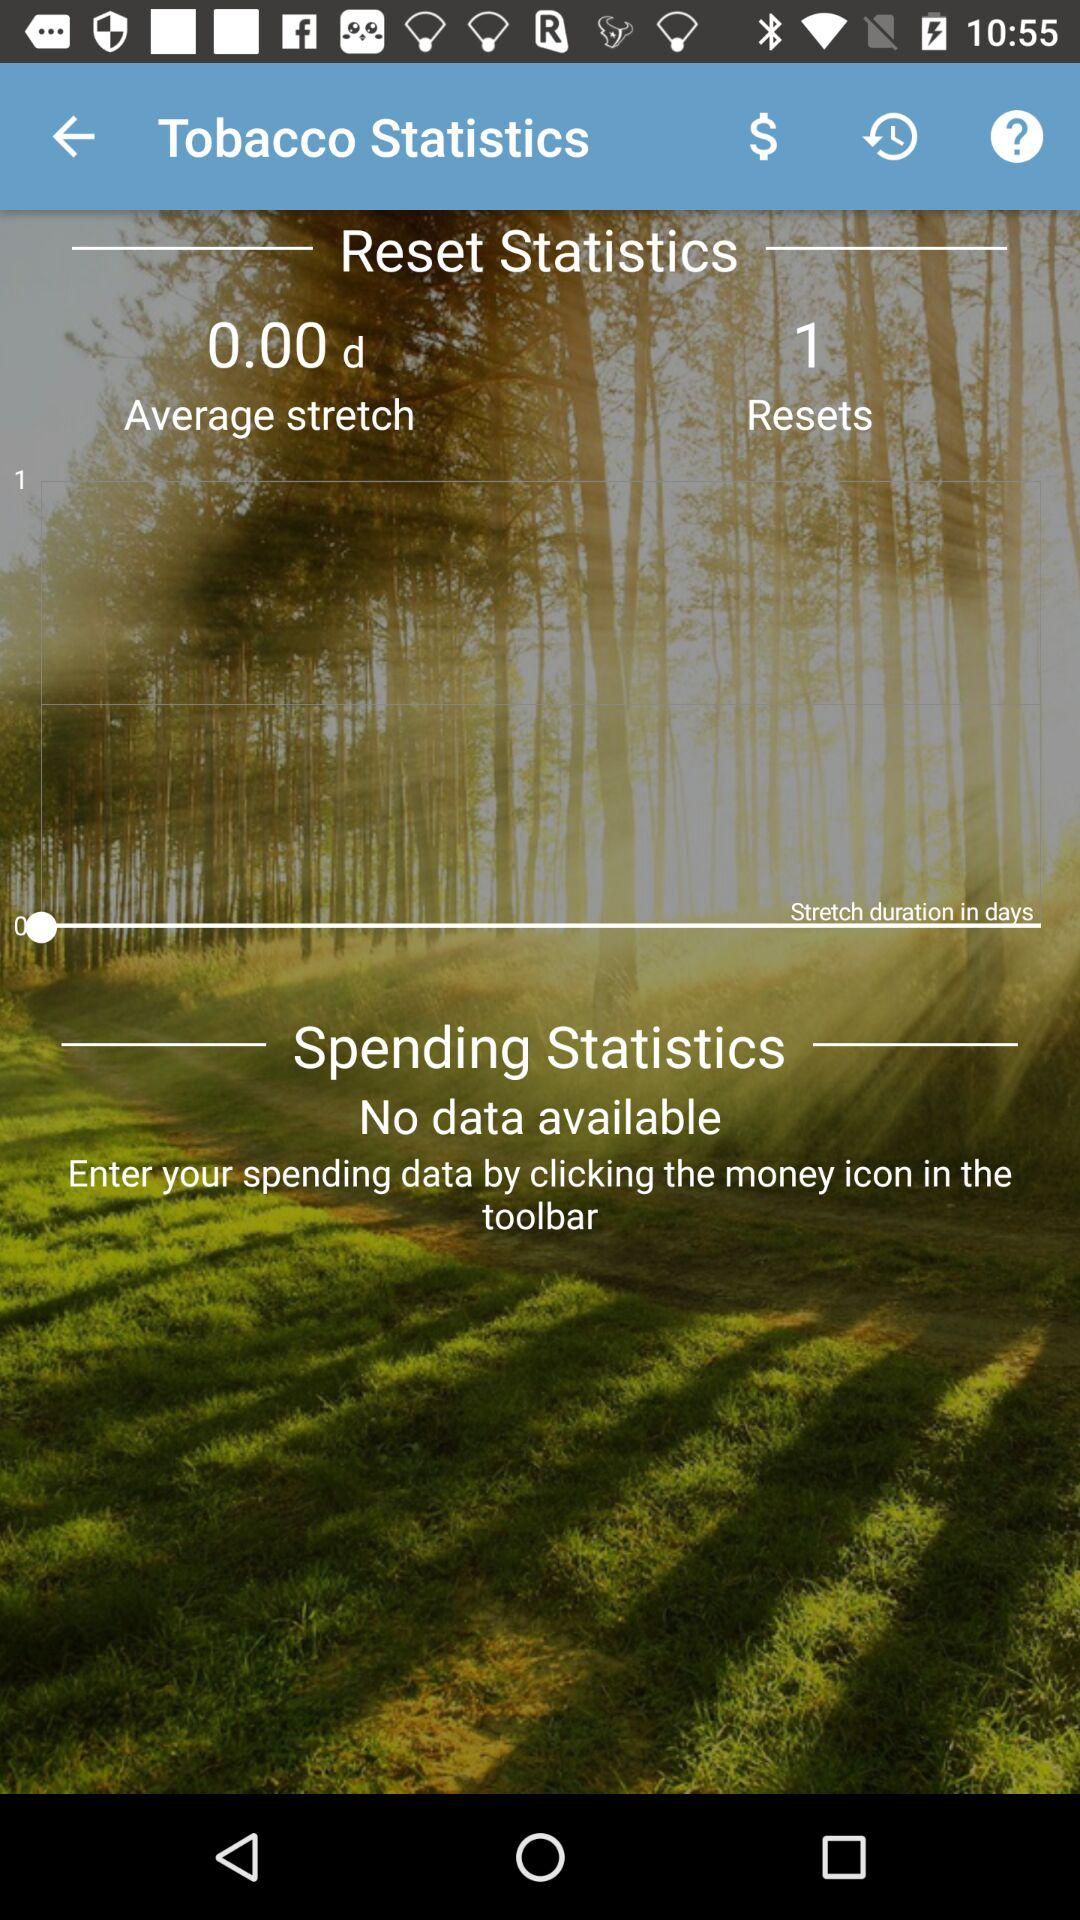How many resets are shown? There is 1 reset. 